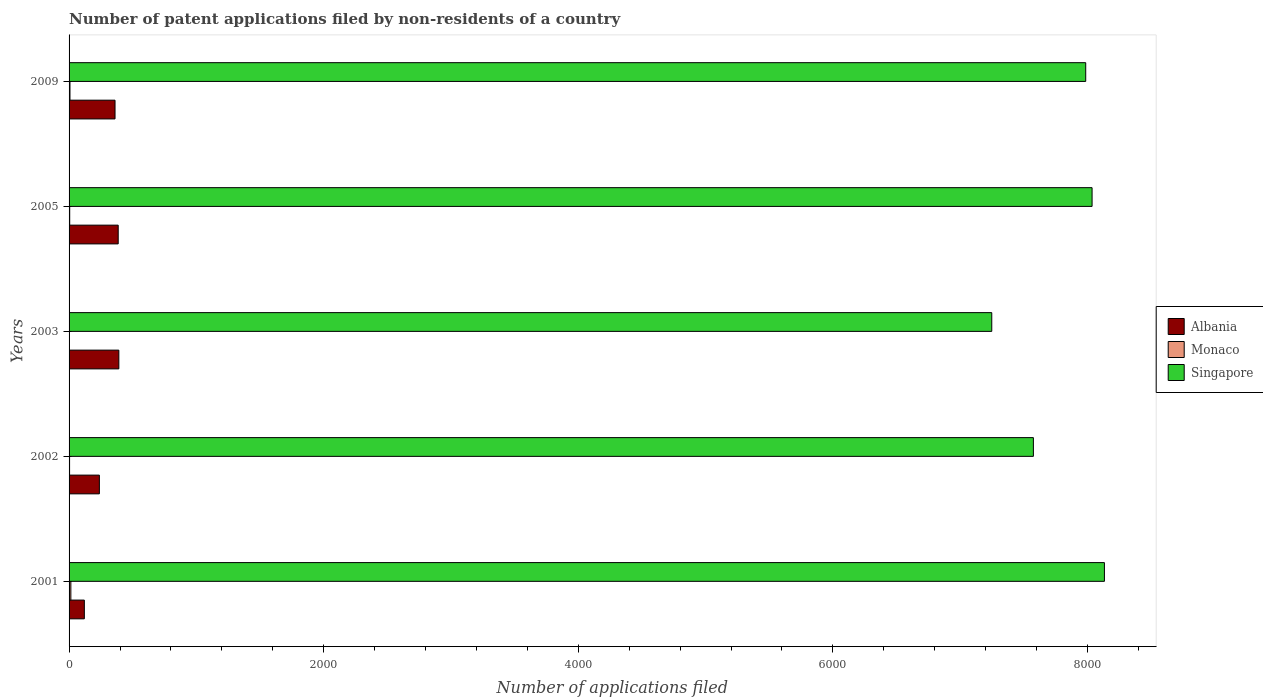How many different coloured bars are there?
Your response must be concise. 3. Are the number of bars per tick equal to the number of legend labels?
Provide a short and direct response. Yes. How many bars are there on the 1st tick from the top?
Your response must be concise. 3. What is the label of the 2nd group of bars from the top?
Make the answer very short. 2005. What is the number of applications filed in Singapore in 2003?
Your answer should be very brief. 7248. Across all years, what is the maximum number of applications filed in Singapore?
Provide a succinct answer. 8133. Across all years, what is the minimum number of applications filed in Singapore?
Offer a terse response. 7248. In which year was the number of applications filed in Singapore maximum?
Give a very brief answer. 2001. What is the total number of applications filed in Singapore in the graph?
Offer a very short reply. 3.90e+04. What is the difference between the number of applications filed in Monaco in 2001 and that in 2005?
Offer a terse response. 9. What is the difference between the number of applications filed in Singapore in 2009 and the number of applications filed in Monaco in 2002?
Keep it short and to the point. 7982. What is the average number of applications filed in Singapore per year?
Keep it short and to the point. 7795.6. In the year 2005, what is the difference between the number of applications filed in Monaco and number of applications filed in Albania?
Offer a terse response. -381. In how many years, is the number of applications filed in Singapore greater than 4800 ?
Your response must be concise. 5. What is the ratio of the number of applications filed in Monaco in 2002 to that in 2009?
Your answer should be compact. 0.57. What is the difference between the highest and the lowest number of applications filed in Albania?
Your answer should be very brief. 271. In how many years, is the number of applications filed in Singapore greater than the average number of applications filed in Singapore taken over all years?
Offer a terse response. 3. Is the sum of the number of applications filed in Monaco in 2001 and 2005 greater than the maximum number of applications filed in Albania across all years?
Make the answer very short. No. What does the 1st bar from the top in 2002 represents?
Your answer should be very brief. Singapore. What does the 1st bar from the bottom in 2003 represents?
Provide a short and direct response. Albania. How many bars are there?
Your response must be concise. 15. Are all the bars in the graph horizontal?
Keep it short and to the point. Yes. How many years are there in the graph?
Give a very brief answer. 5. Does the graph contain any zero values?
Your response must be concise. No. Where does the legend appear in the graph?
Provide a short and direct response. Center right. How many legend labels are there?
Provide a succinct answer. 3. How are the legend labels stacked?
Offer a very short reply. Vertical. What is the title of the graph?
Offer a very short reply. Number of patent applications filed by non-residents of a country. What is the label or title of the X-axis?
Your answer should be compact. Number of applications filed. What is the Number of applications filed in Albania in 2001?
Offer a terse response. 120. What is the Number of applications filed in Monaco in 2001?
Give a very brief answer. 14. What is the Number of applications filed in Singapore in 2001?
Give a very brief answer. 8133. What is the Number of applications filed in Albania in 2002?
Your answer should be very brief. 238. What is the Number of applications filed of Monaco in 2002?
Keep it short and to the point. 4. What is the Number of applications filed of Singapore in 2002?
Your answer should be very brief. 7575. What is the Number of applications filed in Albania in 2003?
Offer a terse response. 391. What is the Number of applications filed in Monaco in 2003?
Provide a succinct answer. 3. What is the Number of applications filed of Singapore in 2003?
Offer a very short reply. 7248. What is the Number of applications filed in Albania in 2005?
Provide a short and direct response. 386. What is the Number of applications filed in Singapore in 2005?
Your response must be concise. 8036. What is the Number of applications filed in Albania in 2009?
Your answer should be compact. 361. What is the Number of applications filed of Singapore in 2009?
Offer a very short reply. 7986. Across all years, what is the maximum Number of applications filed of Albania?
Provide a succinct answer. 391. Across all years, what is the maximum Number of applications filed of Monaco?
Offer a terse response. 14. Across all years, what is the maximum Number of applications filed in Singapore?
Provide a succinct answer. 8133. Across all years, what is the minimum Number of applications filed in Albania?
Provide a succinct answer. 120. Across all years, what is the minimum Number of applications filed of Monaco?
Keep it short and to the point. 3. Across all years, what is the minimum Number of applications filed in Singapore?
Make the answer very short. 7248. What is the total Number of applications filed in Albania in the graph?
Your answer should be very brief. 1496. What is the total Number of applications filed of Singapore in the graph?
Your answer should be very brief. 3.90e+04. What is the difference between the Number of applications filed in Albania in 2001 and that in 2002?
Your answer should be very brief. -118. What is the difference between the Number of applications filed of Singapore in 2001 and that in 2002?
Your response must be concise. 558. What is the difference between the Number of applications filed in Albania in 2001 and that in 2003?
Provide a short and direct response. -271. What is the difference between the Number of applications filed of Monaco in 2001 and that in 2003?
Offer a very short reply. 11. What is the difference between the Number of applications filed in Singapore in 2001 and that in 2003?
Your answer should be very brief. 885. What is the difference between the Number of applications filed of Albania in 2001 and that in 2005?
Provide a short and direct response. -266. What is the difference between the Number of applications filed of Monaco in 2001 and that in 2005?
Provide a succinct answer. 9. What is the difference between the Number of applications filed in Singapore in 2001 and that in 2005?
Keep it short and to the point. 97. What is the difference between the Number of applications filed in Albania in 2001 and that in 2009?
Make the answer very short. -241. What is the difference between the Number of applications filed in Monaco in 2001 and that in 2009?
Offer a very short reply. 7. What is the difference between the Number of applications filed of Singapore in 2001 and that in 2009?
Offer a very short reply. 147. What is the difference between the Number of applications filed in Albania in 2002 and that in 2003?
Provide a succinct answer. -153. What is the difference between the Number of applications filed in Singapore in 2002 and that in 2003?
Your answer should be very brief. 327. What is the difference between the Number of applications filed of Albania in 2002 and that in 2005?
Provide a succinct answer. -148. What is the difference between the Number of applications filed in Singapore in 2002 and that in 2005?
Offer a very short reply. -461. What is the difference between the Number of applications filed in Albania in 2002 and that in 2009?
Provide a short and direct response. -123. What is the difference between the Number of applications filed of Monaco in 2002 and that in 2009?
Give a very brief answer. -3. What is the difference between the Number of applications filed in Singapore in 2002 and that in 2009?
Offer a terse response. -411. What is the difference between the Number of applications filed of Singapore in 2003 and that in 2005?
Provide a short and direct response. -788. What is the difference between the Number of applications filed in Albania in 2003 and that in 2009?
Make the answer very short. 30. What is the difference between the Number of applications filed of Monaco in 2003 and that in 2009?
Ensure brevity in your answer.  -4. What is the difference between the Number of applications filed in Singapore in 2003 and that in 2009?
Your response must be concise. -738. What is the difference between the Number of applications filed in Monaco in 2005 and that in 2009?
Your answer should be very brief. -2. What is the difference between the Number of applications filed in Singapore in 2005 and that in 2009?
Give a very brief answer. 50. What is the difference between the Number of applications filed in Albania in 2001 and the Number of applications filed in Monaco in 2002?
Give a very brief answer. 116. What is the difference between the Number of applications filed of Albania in 2001 and the Number of applications filed of Singapore in 2002?
Your response must be concise. -7455. What is the difference between the Number of applications filed of Monaco in 2001 and the Number of applications filed of Singapore in 2002?
Your response must be concise. -7561. What is the difference between the Number of applications filed of Albania in 2001 and the Number of applications filed of Monaco in 2003?
Your response must be concise. 117. What is the difference between the Number of applications filed in Albania in 2001 and the Number of applications filed in Singapore in 2003?
Keep it short and to the point. -7128. What is the difference between the Number of applications filed in Monaco in 2001 and the Number of applications filed in Singapore in 2003?
Your response must be concise. -7234. What is the difference between the Number of applications filed of Albania in 2001 and the Number of applications filed of Monaco in 2005?
Offer a very short reply. 115. What is the difference between the Number of applications filed in Albania in 2001 and the Number of applications filed in Singapore in 2005?
Provide a short and direct response. -7916. What is the difference between the Number of applications filed of Monaco in 2001 and the Number of applications filed of Singapore in 2005?
Keep it short and to the point. -8022. What is the difference between the Number of applications filed in Albania in 2001 and the Number of applications filed in Monaco in 2009?
Give a very brief answer. 113. What is the difference between the Number of applications filed in Albania in 2001 and the Number of applications filed in Singapore in 2009?
Ensure brevity in your answer.  -7866. What is the difference between the Number of applications filed in Monaco in 2001 and the Number of applications filed in Singapore in 2009?
Make the answer very short. -7972. What is the difference between the Number of applications filed of Albania in 2002 and the Number of applications filed of Monaco in 2003?
Keep it short and to the point. 235. What is the difference between the Number of applications filed in Albania in 2002 and the Number of applications filed in Singapore in 2003?
Provide a succinct answer. -7010. What is the difference between the Number of applications filed of Monaco in 2002 and the Number of applications filed of Singapore in 2003?
Your answer should be very brief. -7244. What is the difference between the Number of applications filed in Albania in 2002 and the Number of applications filed in Monaco in 2005?
Provide a short and direct response. 233. What is the difference between the Number of applications filed in Albania in 2002 and the Number of applications filed in Singapore in 2005?
Your answer should be compact. -7798. What is the difference between the Number of applications filed in Monaco in 2002 and the Number of applications filed in Singapore in 2005?
Your response must be concise. -8032. What is the difference between the Number of applications filed in Albania in 2002 and the Number of applications filed in Monaco in 2009?
Make the answer very short. 231. What is the difference between the Number of applications filed in Albania in 2002 and the Number of applications filed in Singapore in 2009?
Make the answer very short. -7748. What is the difference between the Number of applications filed in Monaco in 2002 and the Number of applications filed in Singapore in 2009?
Your answer should be very brief. -7982. What is the difference between the Number of applications filed of Albania in 2003 and the Number of applications filed of Monaco in 2005?
Your response must be concise. 386. What is the difference between the Number of applications filed in Albania in 2003 and the Number of applications filed in Singapore in 2005?
Make the answer very short. -7645. What is the difference between the Number of applications filed of Monaco in 2003 and the Number of applications filed of Singapore in 2005?
Ensure brevity in your answer.  -8033. What is the difference between the Number of applications filed of Albania in 2003 and the Number of applications filed of Monaco in 2009?
Make the answer very short. 384. What is the difference between the Number of applications filed of Albania in 2003 and the Number of applications filed of Singapore in 2009?
Your answer should be very brief. -7595. What is the difference between the Number of applications filed in Monaco in 2003 and the Number of applications filed in Singapore in 2009?
Give a very brief answer. -7983. What is the difference between the Number of applications filed in Albania in 2005 and the Number of applications filed in Monaco in 2009?
Make the answer very short. 379. What is the difference between the Number of applications filed in Albania in 2005 and the Number of applications filed in Singapore in 2009?
Provide a short and direct response. -7600. What is the difference between the Number of applications filed in Monaco in 2005 and the Number of applications filed in Singapore in 2009?
Your answer should be compact. -7981. What is the average Number of applications filed of Albania per year?
Make the answer very short. 299.2. What is the average Number of applications filed in Monaco per year?
Your response must be concise. 6.6. What is the average Number of applications filed of Singapore per year?
Offer a very short reply. 7795.6. In the year 2001, what is the difference between the Number of applications filed of Albania and Number of applications filed of Monaco?
Offer a very short reply. 106. In the year 2001, what is the difference between the Number of applications filed of Albania and Number of applications filed of Singapore?
Give a very brief answer. -8013. In the year 2001, what is the difference between the Number of applications filed of Monaco and Number of applications filed of Singapore?
Make the answer very short. -8119. In the year 2002, what is the difference between the Number of applications filed of Albania and Number of applications filed of Monaco?
Offer a very short reply. 234. In the year 2002, what is the difference between the Number of applications filed in Albania and Number of applications filed in Singapore?
Offer a very short reply. -7337. In the year 2002, what is the difference between the Number of applications filed of Monaco and Number of applications filed of Singapore?
Provide a succinct answer. -7571. In the year 2003, what is the difference between the Number of applications filed in Albania and Number of applications filed in Monaco?
Provide a short and direct response. 388. In the year 2003, what is the difference between the Number of applications filed in Albania and Number of applications filed in Singapore?
Offer a very short reply. -6857. In the year 2003, what is the difference between the Number of applications filed of Monaco and Number of applications filed of Singapore?
Make the answer very short. -7245. In the year 2005, what is the difference between the Number of applications filed in Albania and Number of applications filed in Monaco?
Keep it short and to the point. 381. In the year 2005, what is the difference between the Number of applications filed in Albania and Number of applications filed in Singapore?
Keep it short and to the point. -7650. In the year 2005, what is the difference between the Number of applications filed in Monaco and Number of applications filed in Singapore?
Give a very brief answer. -8031. In the year 2009, what is the difference between the Number of applications filed of Albania and Number of applications filed of Monaco?
Provide a short and direct response. 354. In the year 2009, what is the difference between the Number of applications filed of Albania and Number of applications filed of Singapore?
Make the answer very short. -7625. In the year 2009, what is the difference between the Number of applications filed of Monaco and Number of applications filed of Singapore?
Give a very brief answer. -7979. What is the ratio of the Number of applications filed of Albania in 2001 to that in 2002?
Offer a terse response. 0.5. What is the ratio of the Number of applications filed in Monaco in 2001 to that in 2002?
Your response must be concise. 3.5. What is the ratio of the Number of applications filed in Singapore in 2001 to that in 2002?
Give a very brief answer. 1.07. What is the ratio of the Number of applications filed of Albania in 2001 to that in 2003?
Provide a succinct answer. 0.31. What is the ratio of the Number of applications filed of Monaco in 2001 to that in 2003?
Offer a terse response. 4.67. What is the ratio of the Number of applications filed of Singapore in 2001 to that in 2003?
Ensure brevity in your answer.  1.12. What is the ratio of the Number of applications filed in Albania in 2001 to that in 2005?
Provide a succinct answer. 0.31. What is the ratio of the Number of applications filed of Monaco in 2001 to that in 2005?
Provide a succinct answer. 2.8. What is the ratio of the Number of applications filed in Singapore in 2001 to that in 2005?
Provide a succinct answer. 1.01. What is the ratio of the Number of applications filed of Albania in 2001 to that in 2009?
Ensure brevity in your answer.  0.33. What is the ratio of the Number of applications filed of Monaco in 2001 to that in 2009?
Offer a very short reply. 2. What is the ratio of the Number of applications filed of Singapore in 2001 to that in 2009?
Provide a succinct answer. 1.02. What is the ratio of the Number of applications filed of Albania in 2002 to that in 2003?
Your answer should be very brief. 0.61. What is the ratio of the Number of applications filed in Monaco in 2002 to that in 2003?
Ensure brevity in your answer.  1.33. What is the ratio of the Number of applications filed in Singapore in 2002 to that in 2003?
Offer a terse response. 1.05. What is the ratio of the Number of applications filed of Albania in 2002 to that in 2005?
Provide a short and direct response. 0.62. What is the ratio of the Number of applications filed in Monaco in 2002 to that in 2005?
Ensure brevity in your answer.  0.8. What is the ratio of the Number of applications filed in Singapore in 2002 to that in 2005?
Ensure brevity in your answer.  0.94. What is the ratio of the Number of applications filed of Albania in 2002 to that in 2009?
Give a very brief answer. 0.66. What is the ratio of the Number of applications filed in Singapore in 2002 to that in 2009?
Provide a succinct answer. 0.95. What is the ratio of the Number of applications filed in Singapore in 2003 to that in 2005?
Your answer should be compact. 0.9. What is the ratio of the Number of applications filed of Albania in 2003 to that in 2009?
Provide a succinct answer. 1.08. What is the ratio of the Number of applications filed of Monaco in 2003 to that in 2009?
Ensure brevity in your answer.  0.43. What is the ratio of the Number of applications filed in Singapore in 2003 to that in 2009?
Offer a terse response. 0.91. What is the ratio of the Number of applications filed of Albania in 2005 to that in 2009?
Your answer should be very brief. 1.07. What is the difference between the highest and the second highest Number of applications filed of Singapore?
Offer a terse response. 97. What is the difference between the highest and the lowest Number of applications filed in Albania?
Offer a terse response. 271. What is the difference between the highest and the lowest Number of applications filed in Monaco?
Ensure brevity in your answer.  11. What is the difference between the highest and the lowest Number of applications filed of Singapore?
Offer a very short reply. 885. 